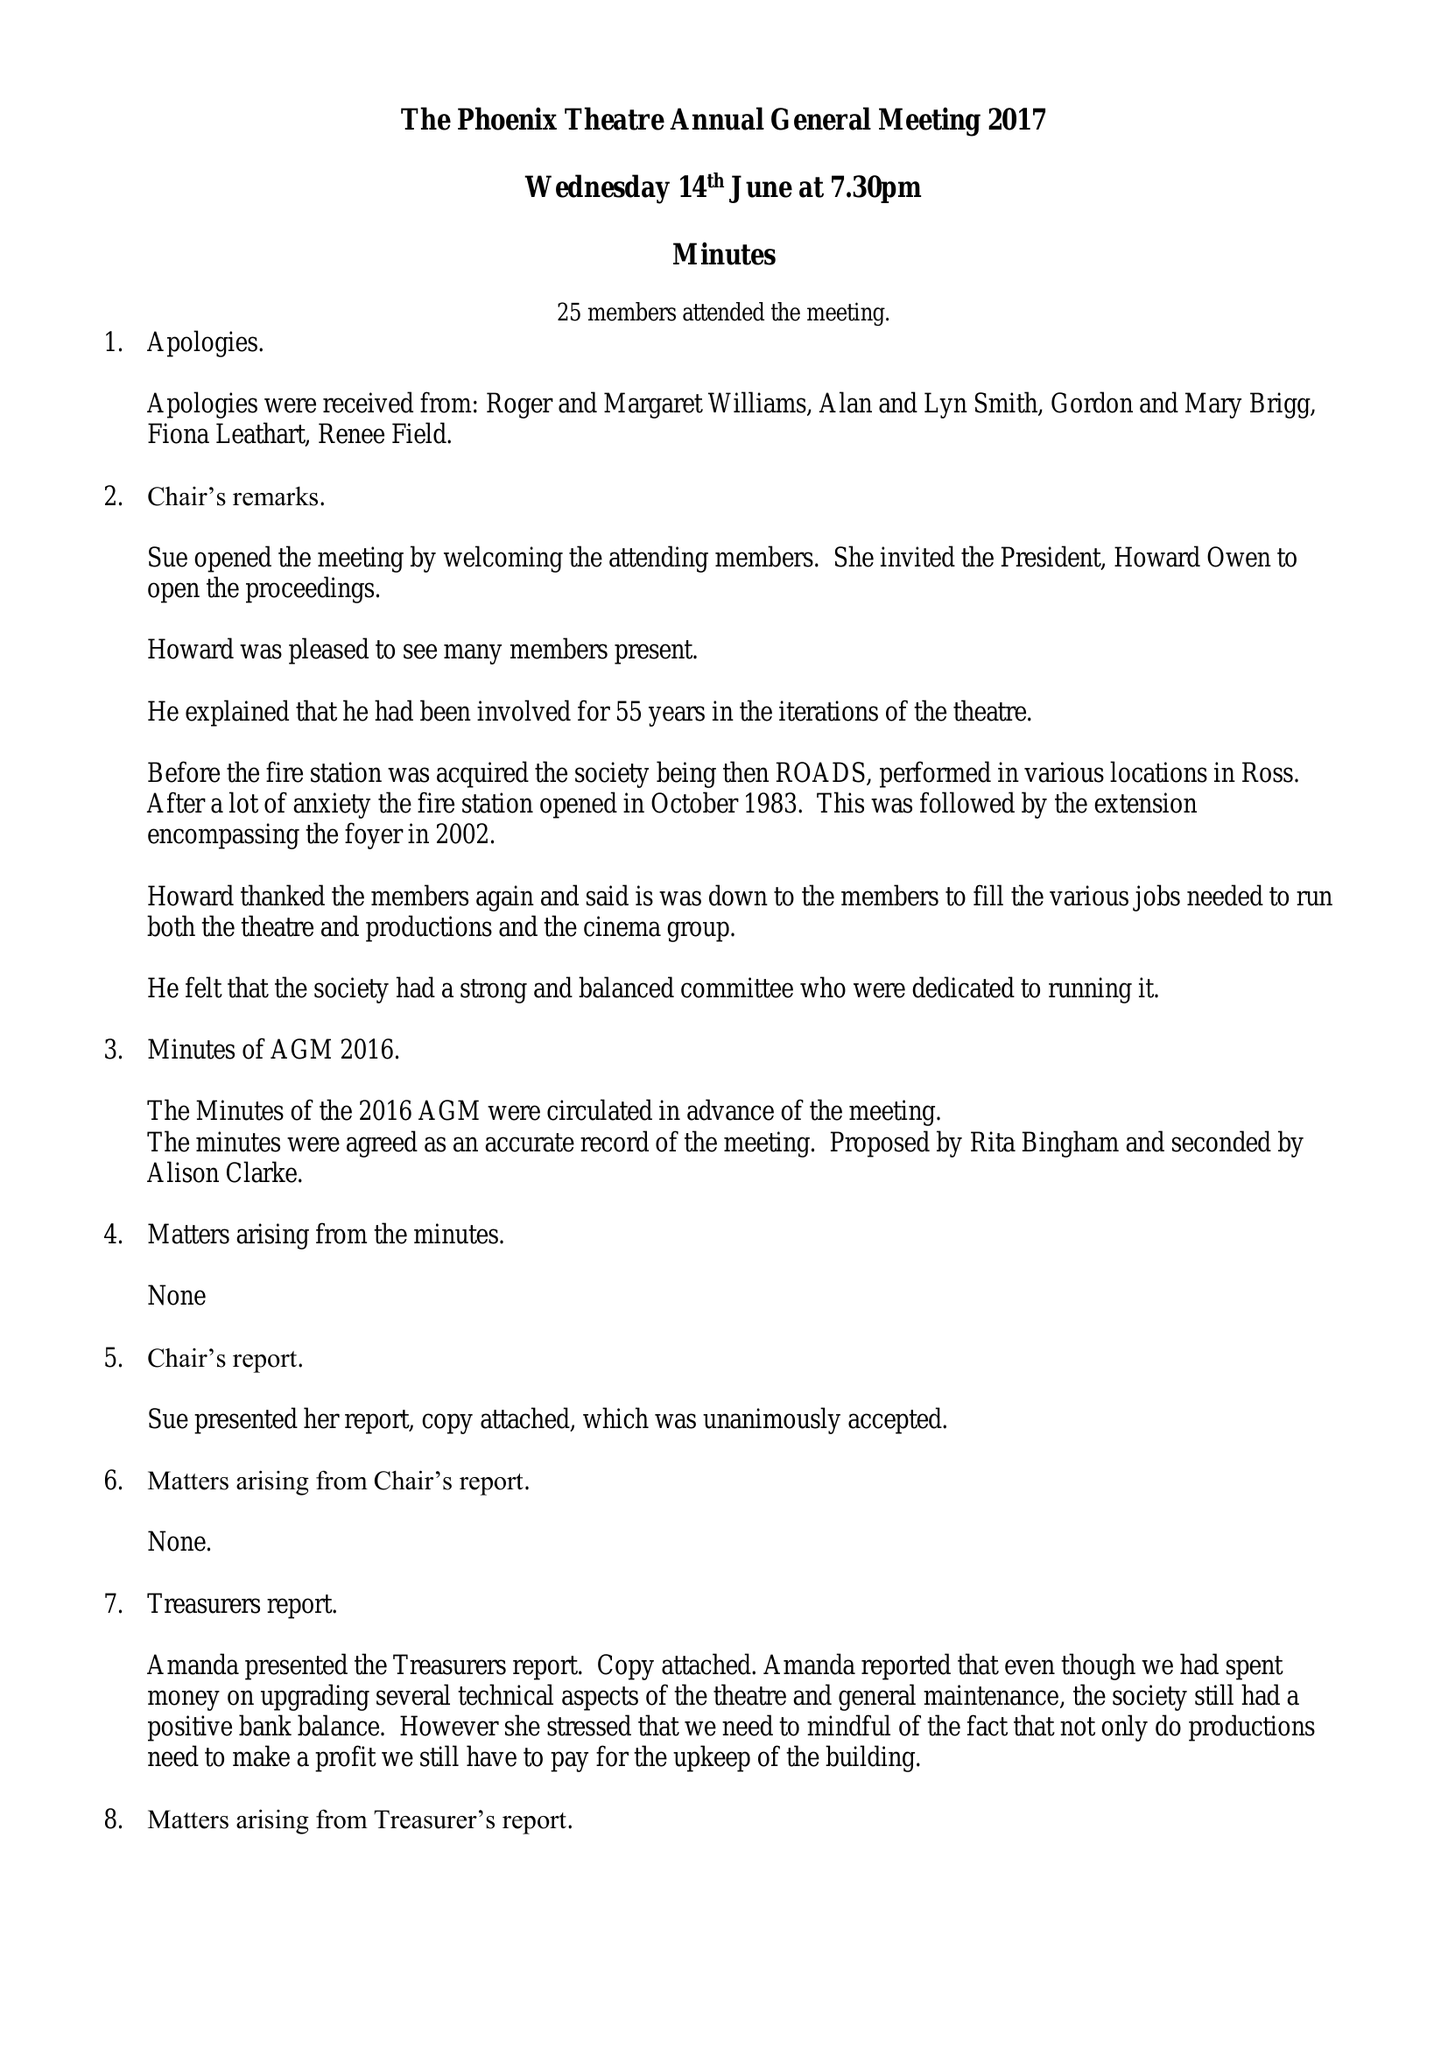What is the value for the spending_annually_in_british_pounds?
Answer the question using a single word or phrase. 38109.56 